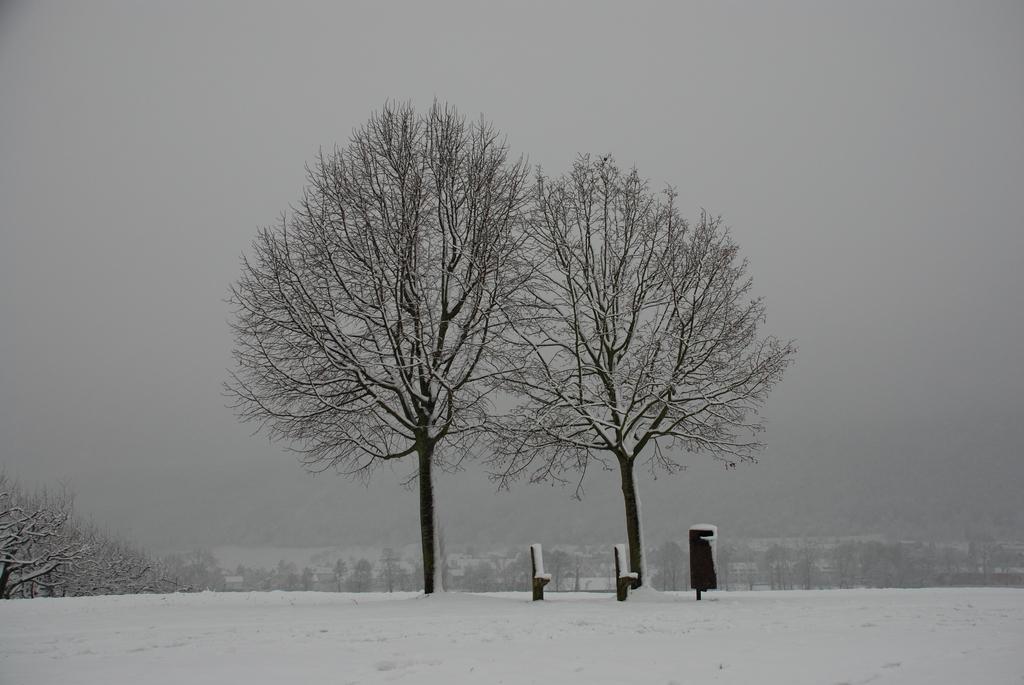Please provide a concise description of this image. In this image I can see the snow, few trees and few black colored objects. In the background I can see few trees and the fog. 